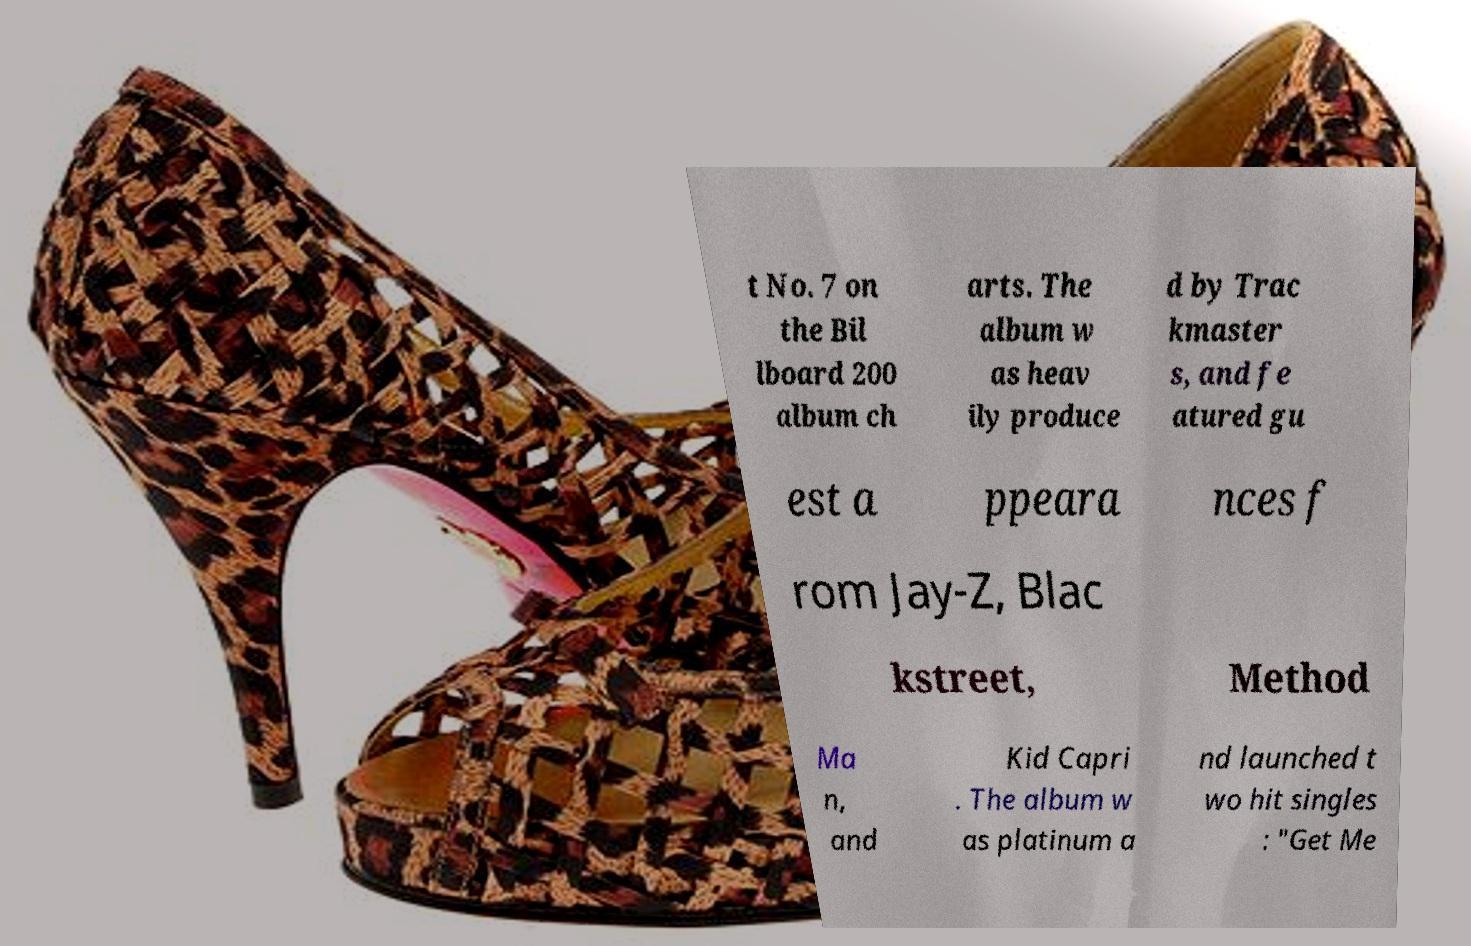What messages or text are displayed in this image? I need them in a readable, typed format. t No. 7 on the Bil lboard 200 album ch arts. The album w as heav ily produce d by Trac kmaster s, and fe atured gu est a ppeara nces f rom Jay-Z, Blac kstreet, Method Ma n, and Kid Capri . The album w as platinum a nd launched t wo hit singles : "Get Me 